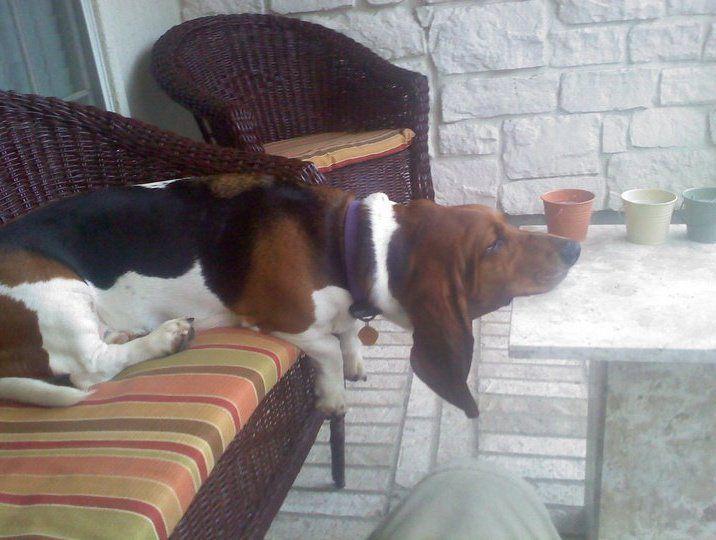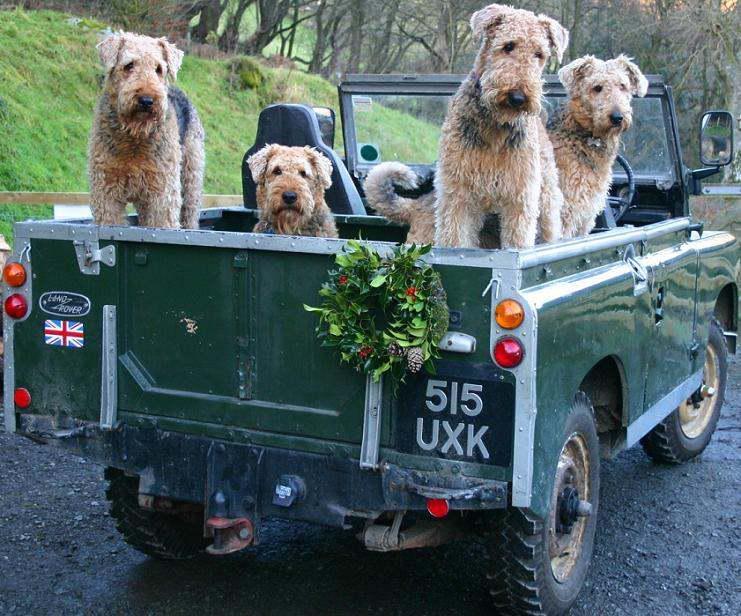The first image is the image on the left, the second image is the image on the right. Analyze the images presented: Is the assertion "At least one dog is laying down." valid? Answer yes or no. Yes. The first image is the image on the left, the second image is the image on the right. Analyze the images presented: Is the assertion "In one of the images, there are at least four dogs." valid? Answer yes or no. Yes. 